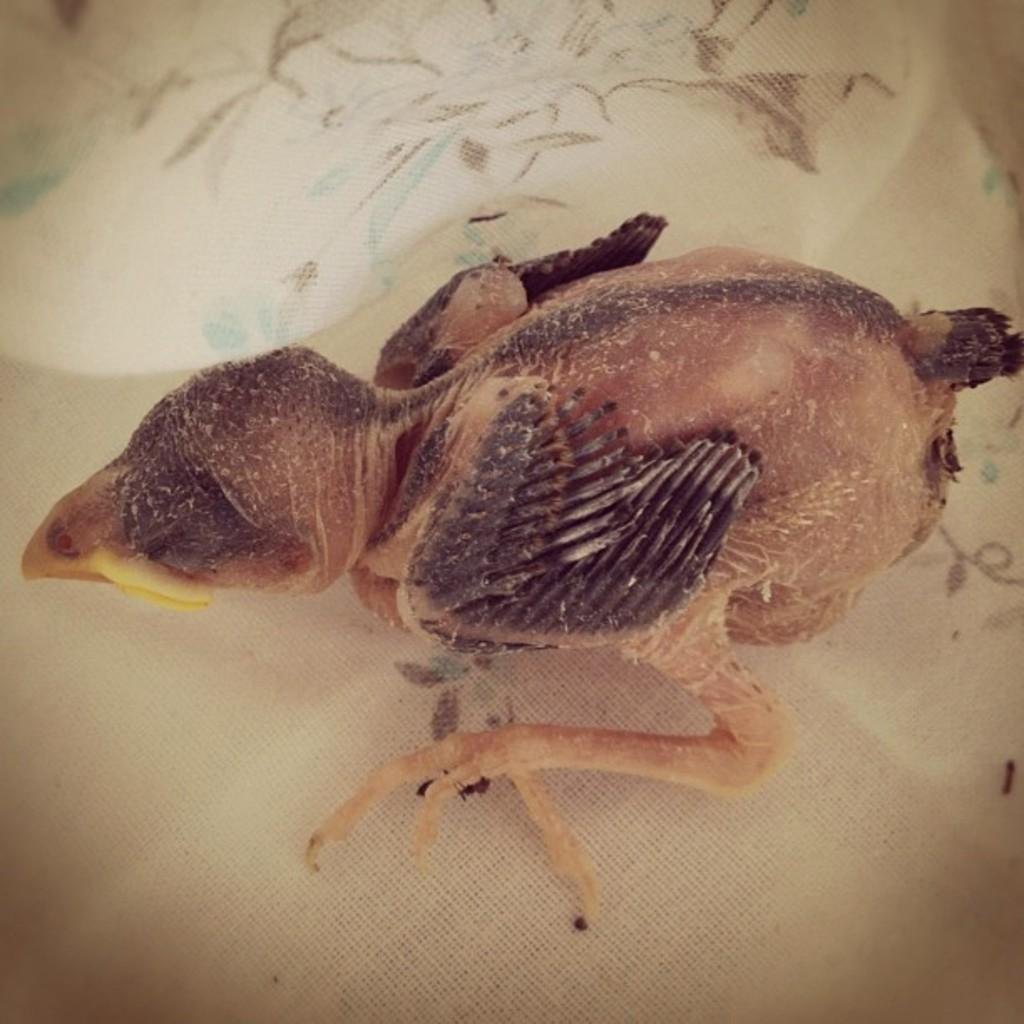What type of animal is present in the image? There is a bird in the image. Where is the bird located? The bird is on a cloth. What type of knowledge is being protested by the bird in the image? There is no protest or knowledge being depicted in the image; it simply features a bird on a cloth. 